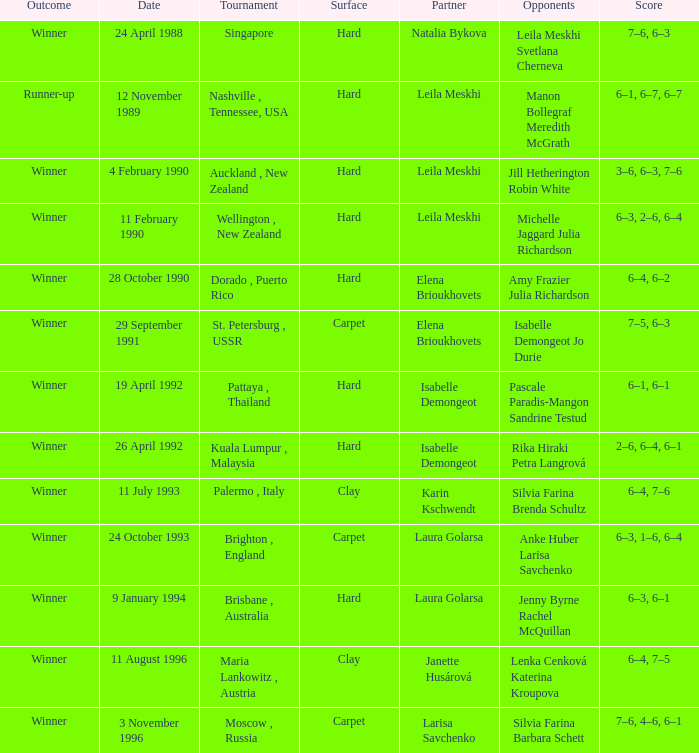On what Date was the Score 6–4, 6–2? 28 October 1990. 